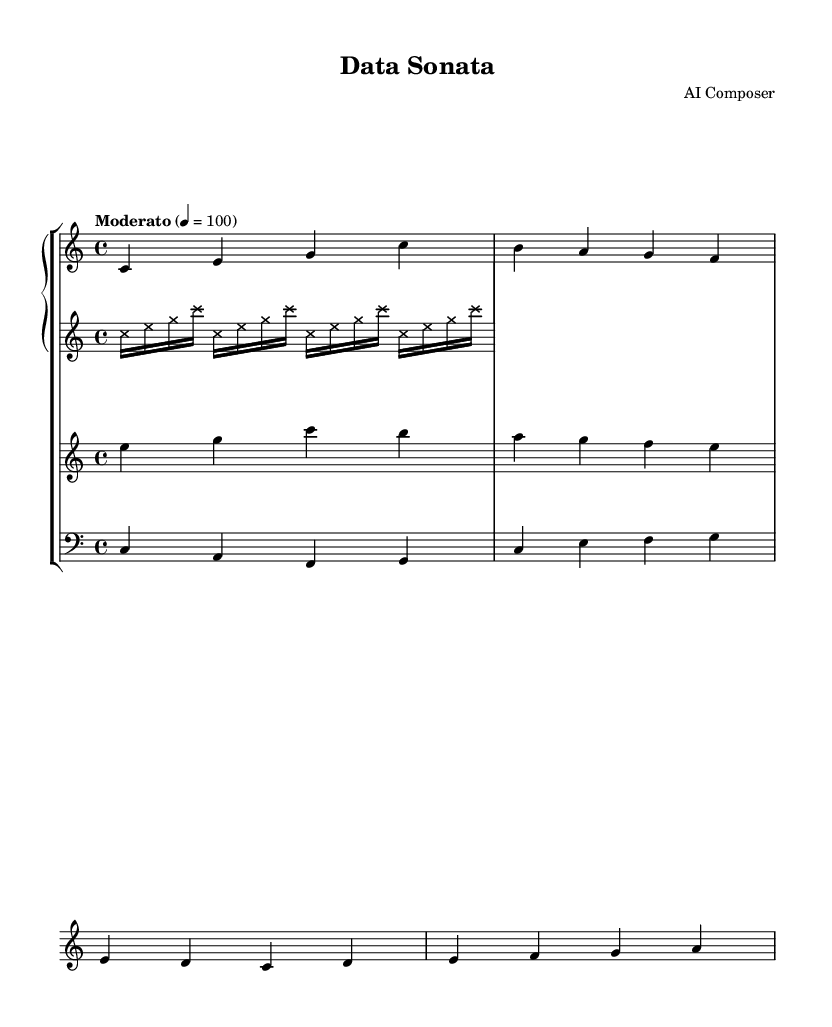What is the key signature of this music? The key signature is C major, which has no sharps or flats.
Answer: C major What is the time signature of this music? The time signature indicated at the beginning of the score is 4/4, which means there are four beats in each measure.
Answer: 4/4 What is the tempo marking of this piece? The tempo marking in the score is indicated as "Moderato" with a metronome marking of quarter note = 100 beats per minute.
Answer: Moderato How many measures are present in the piano part? By counting the measures in the piano part of the score, there are a total of 4 measures.
Answer: 4 Which instrument has a clef at the bass? The cello part is notated in bass clef, indicating it is the instrument using the bass clef.
Answer: Cello What is the pattern of the synthesizer part? The synthesizer part consists of repeating groups of sixteenth notes, specifically the notes C, E, and G.
Answer: Repeating sixteenth notes How many different instruments are included in this score? There are four different instruments represented in this score: piano, synthesizer, violin, and cello.
Answer: Four 